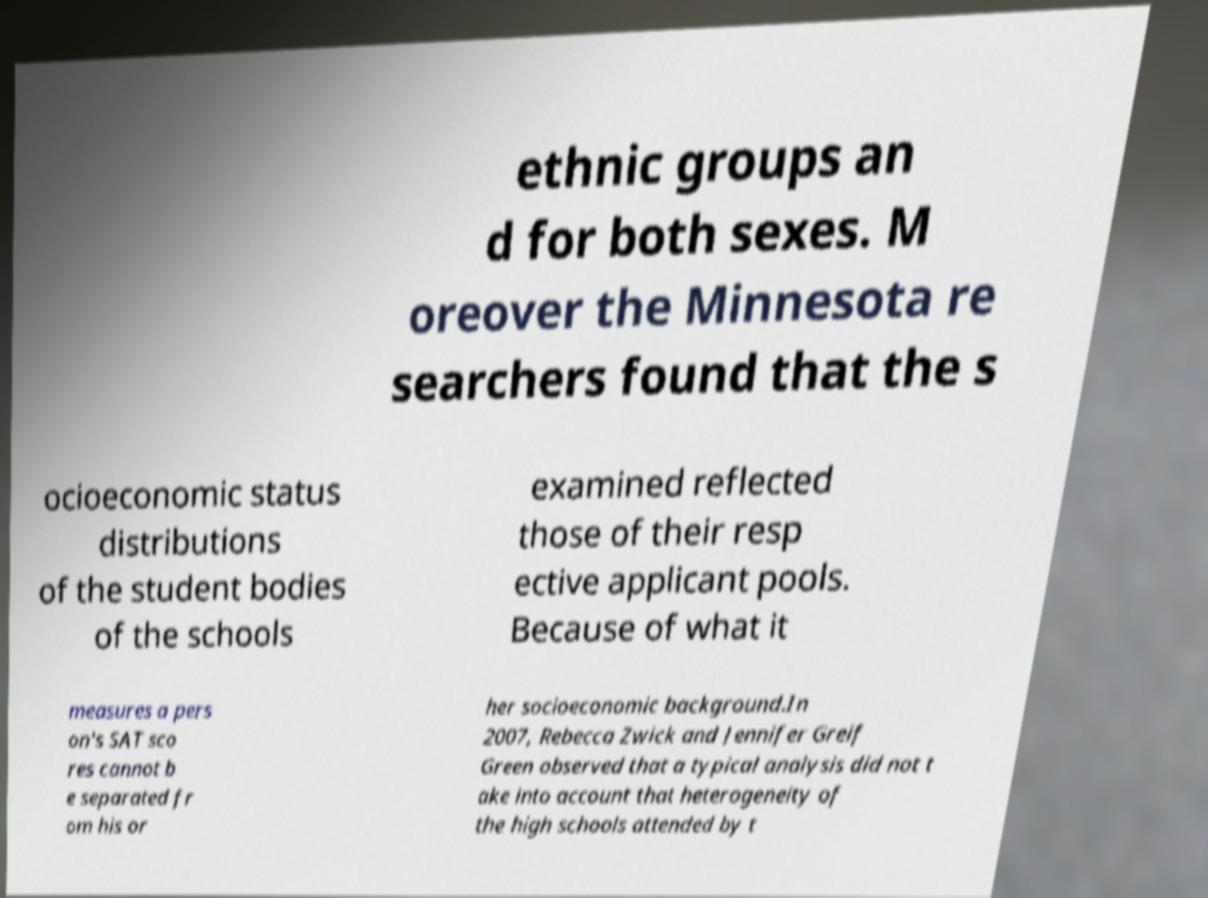Could you assist in decoding the text presented in this image and type it out clearly? ethnic groups an d for both sexes. M oreover the Minnesota re searchers found that the s ocioeconomic status distributions of the student bodies of the schools examined reflected those of their resp ective applicant pools. Because of what it measures a pers on's SAT sco res cannot b e separated fr om his or her socioeconomic background.In 2007, Rebecca Zwick and Jennifer Greif Green observed that a typical analysis did not t ake into account that heterogeneity of the high schools attended by t 